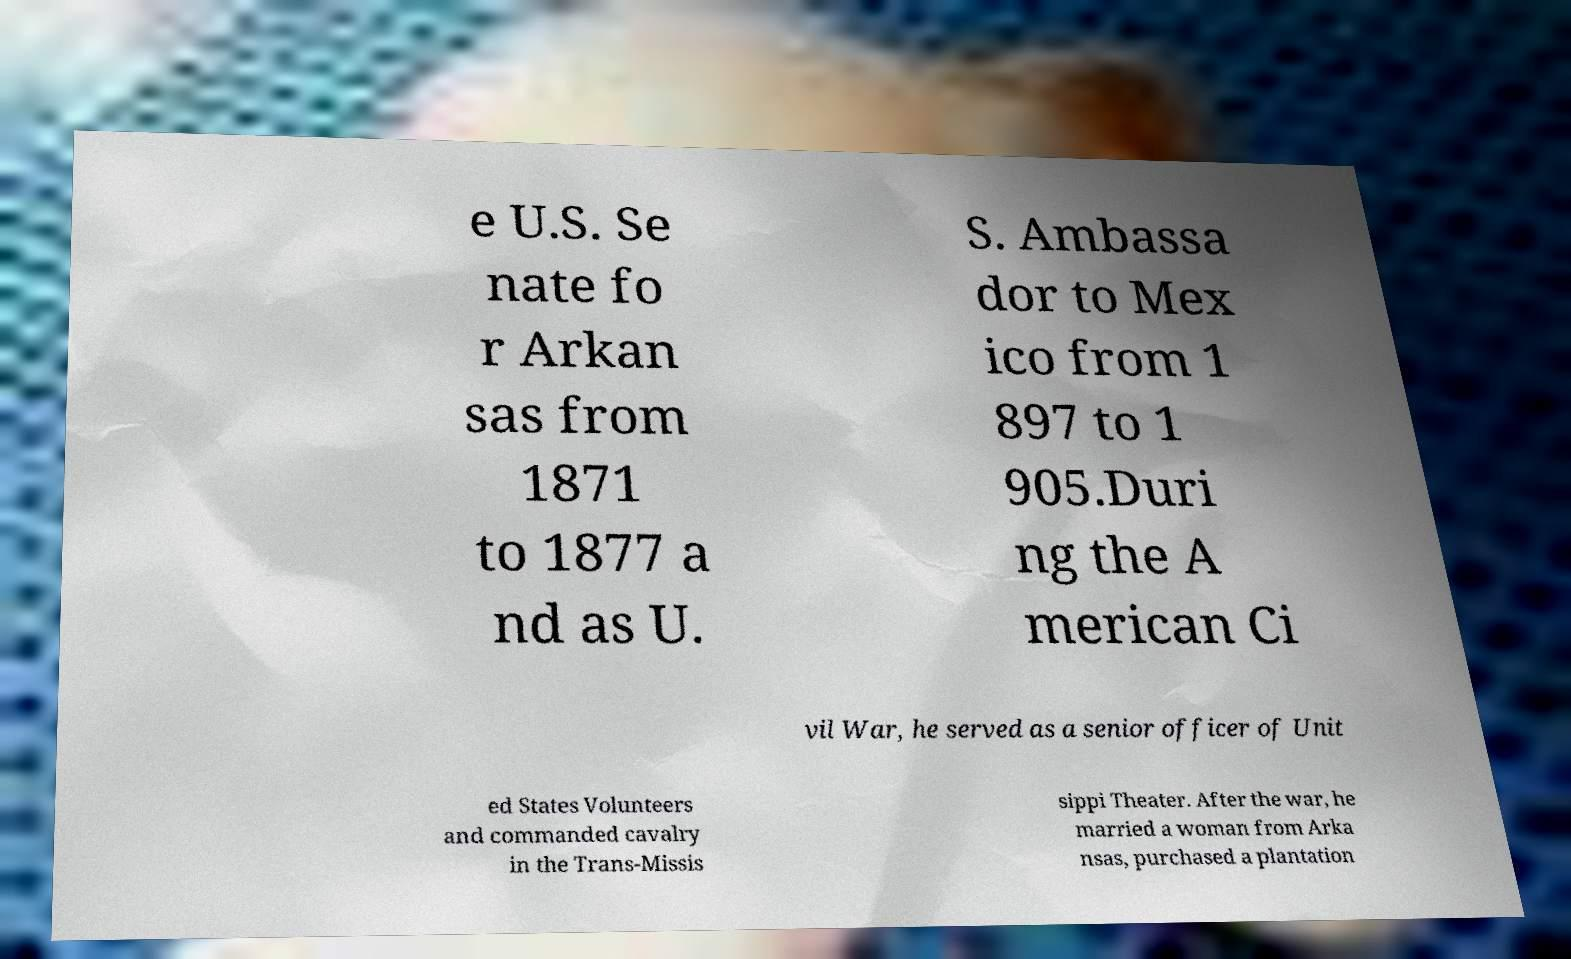Can you read and provide the text displayed in the image?This photo seems to have some interesting text. Can you extract and type it out for me? e U.S. Se nate fo r Arkan sas from 1871 to 1877 a nd as U. S. Ambassa dor to Mex ico from 1 897 to 1 905.Duri ng the A merican Ci vil War, he served as a senior officer of Unit ed States Volunteers and commanded cavalry in the Trans-Missis sippi Theater. After the war, he married a woman from Arka nsas, purchased a plantation 